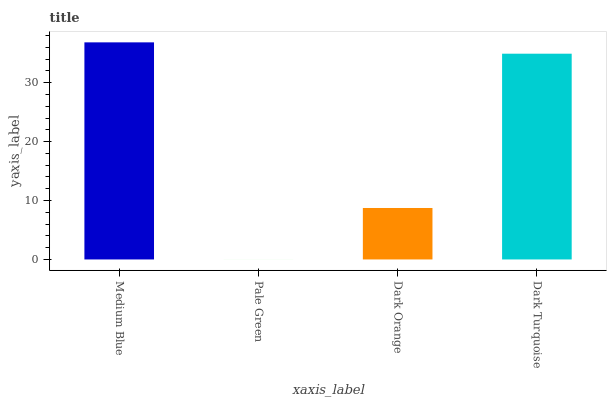Is Pale Green the minimum?
Answer yes or no. Yes. Is Medium Blue the maximum?
Answer yes or no. Yes. Is Dark Orange the minimum?
Answer yes or no. No. Is Dark Orange the maximum?
Answer yes or no. No. Is Dark Orange greater than Pale Green?
Answer yes or no. Yes. Is Pale Green less than Dark Orange?
Answer yes or no. Yes. Is Pale Green greater than Dark Orange?
Answer yes or no. No. Is Dark Orange less than Pale Green?
Answer yes or no. No. Is Dark Turquoise the high median?
Answer yes or no. Yes. Is Dark Orange the low median?
Answer yes or no. Yes. Is Pale Green the high median?
Answer yes or no. No. Is Medium Blue the low median?
Answer yes or no. No. 